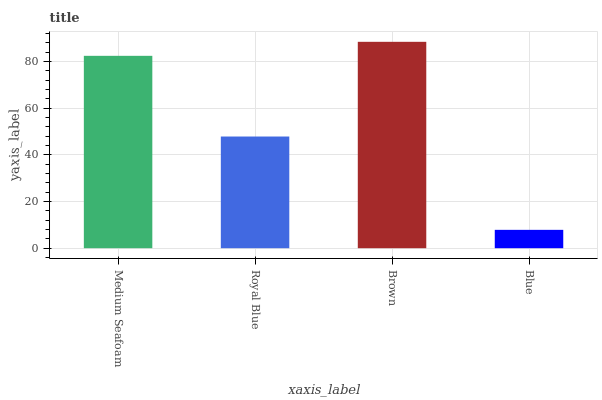Is Royal Blue the minimum?
Answer yes or no. No. Is Royal Blue the maximum?
Answer yes or no. No. Is Medium Seafoam greater than Royal Blue?
Answer yes or no. Yes. Is Royal Blue less than Medium Seafoam?
Answer yes or no. Yes. Is Royal Blue greater than Medium Seafoam?
Answer yes or no. No. Is Medium Seafoam less than Royal Blue?
Answer yes or no. No. Is Medium Seafoam the high median?
Answer yes or no. Yes. Is Royal Blue the low median?
Answer yes or no. Yes. Is Royal Blue the high median?
Answer yes or no. No. Is Blue the low median?
Answer yes or no. No. 